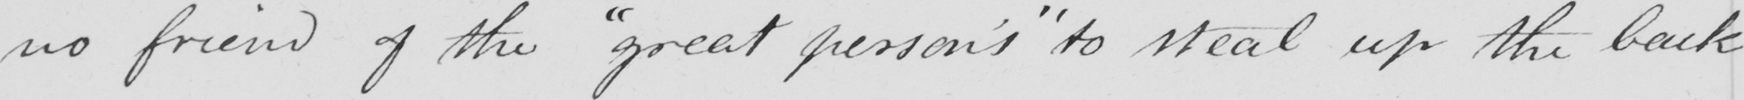Can you read and transcribe this handwriting? no friend of the  " great person ' s "  to steal up the back 